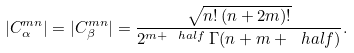<formula> <loc_0><loc_0><loc_500><loc_500>| C _ { \alpha } ^ { m n } | = | C _ { \beta } ^ { m n } | = \frac { \sqrt { n ! \, ( n + 2 m ) ! } } { 2 ^ { m + \ h a l f } \, \Gamma ( n + m + \ h a l f ) } .</formula> 